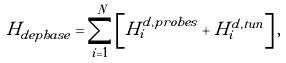Convert formula to latex. <formula><loc_0><loc_0><loc_500><loc_500>H _ { d e p h a s e } = \sum _ { i = 1 } ^ { N } \left [ H _ { i } ^ { d , p r o b e s } + H _ { i } ^ { d , t u n } \right ] ,</formula> 